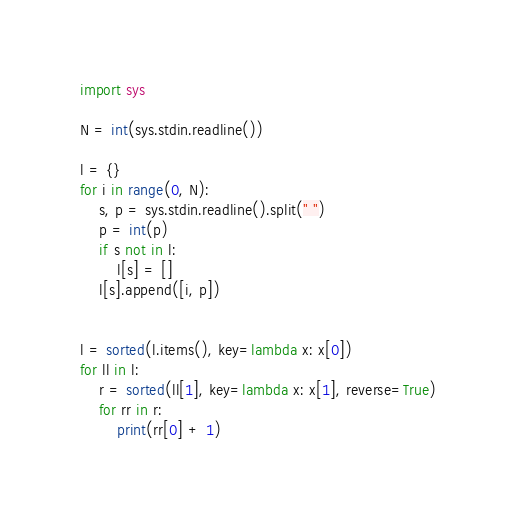Convert code to text. <code><loc_0><loc_0><loc_500><loc_500><_Python_>import sys

N = int(sys.stdin.readline())

l = {}
for i in range(0, N):
    s, p = sys.stdin.readline().split(" ")
    p = int(p)
    if s not in l:
        l[s] = []
    l[s].append([i, p])


l = sorted(l.items(), key=lambda x: x[0])
for ll in l:
    r = sorted(ll[1], key=lambda x: x[1], reverse=True)
    for rr in r:
        print(rr[0] + 1)
</code> 